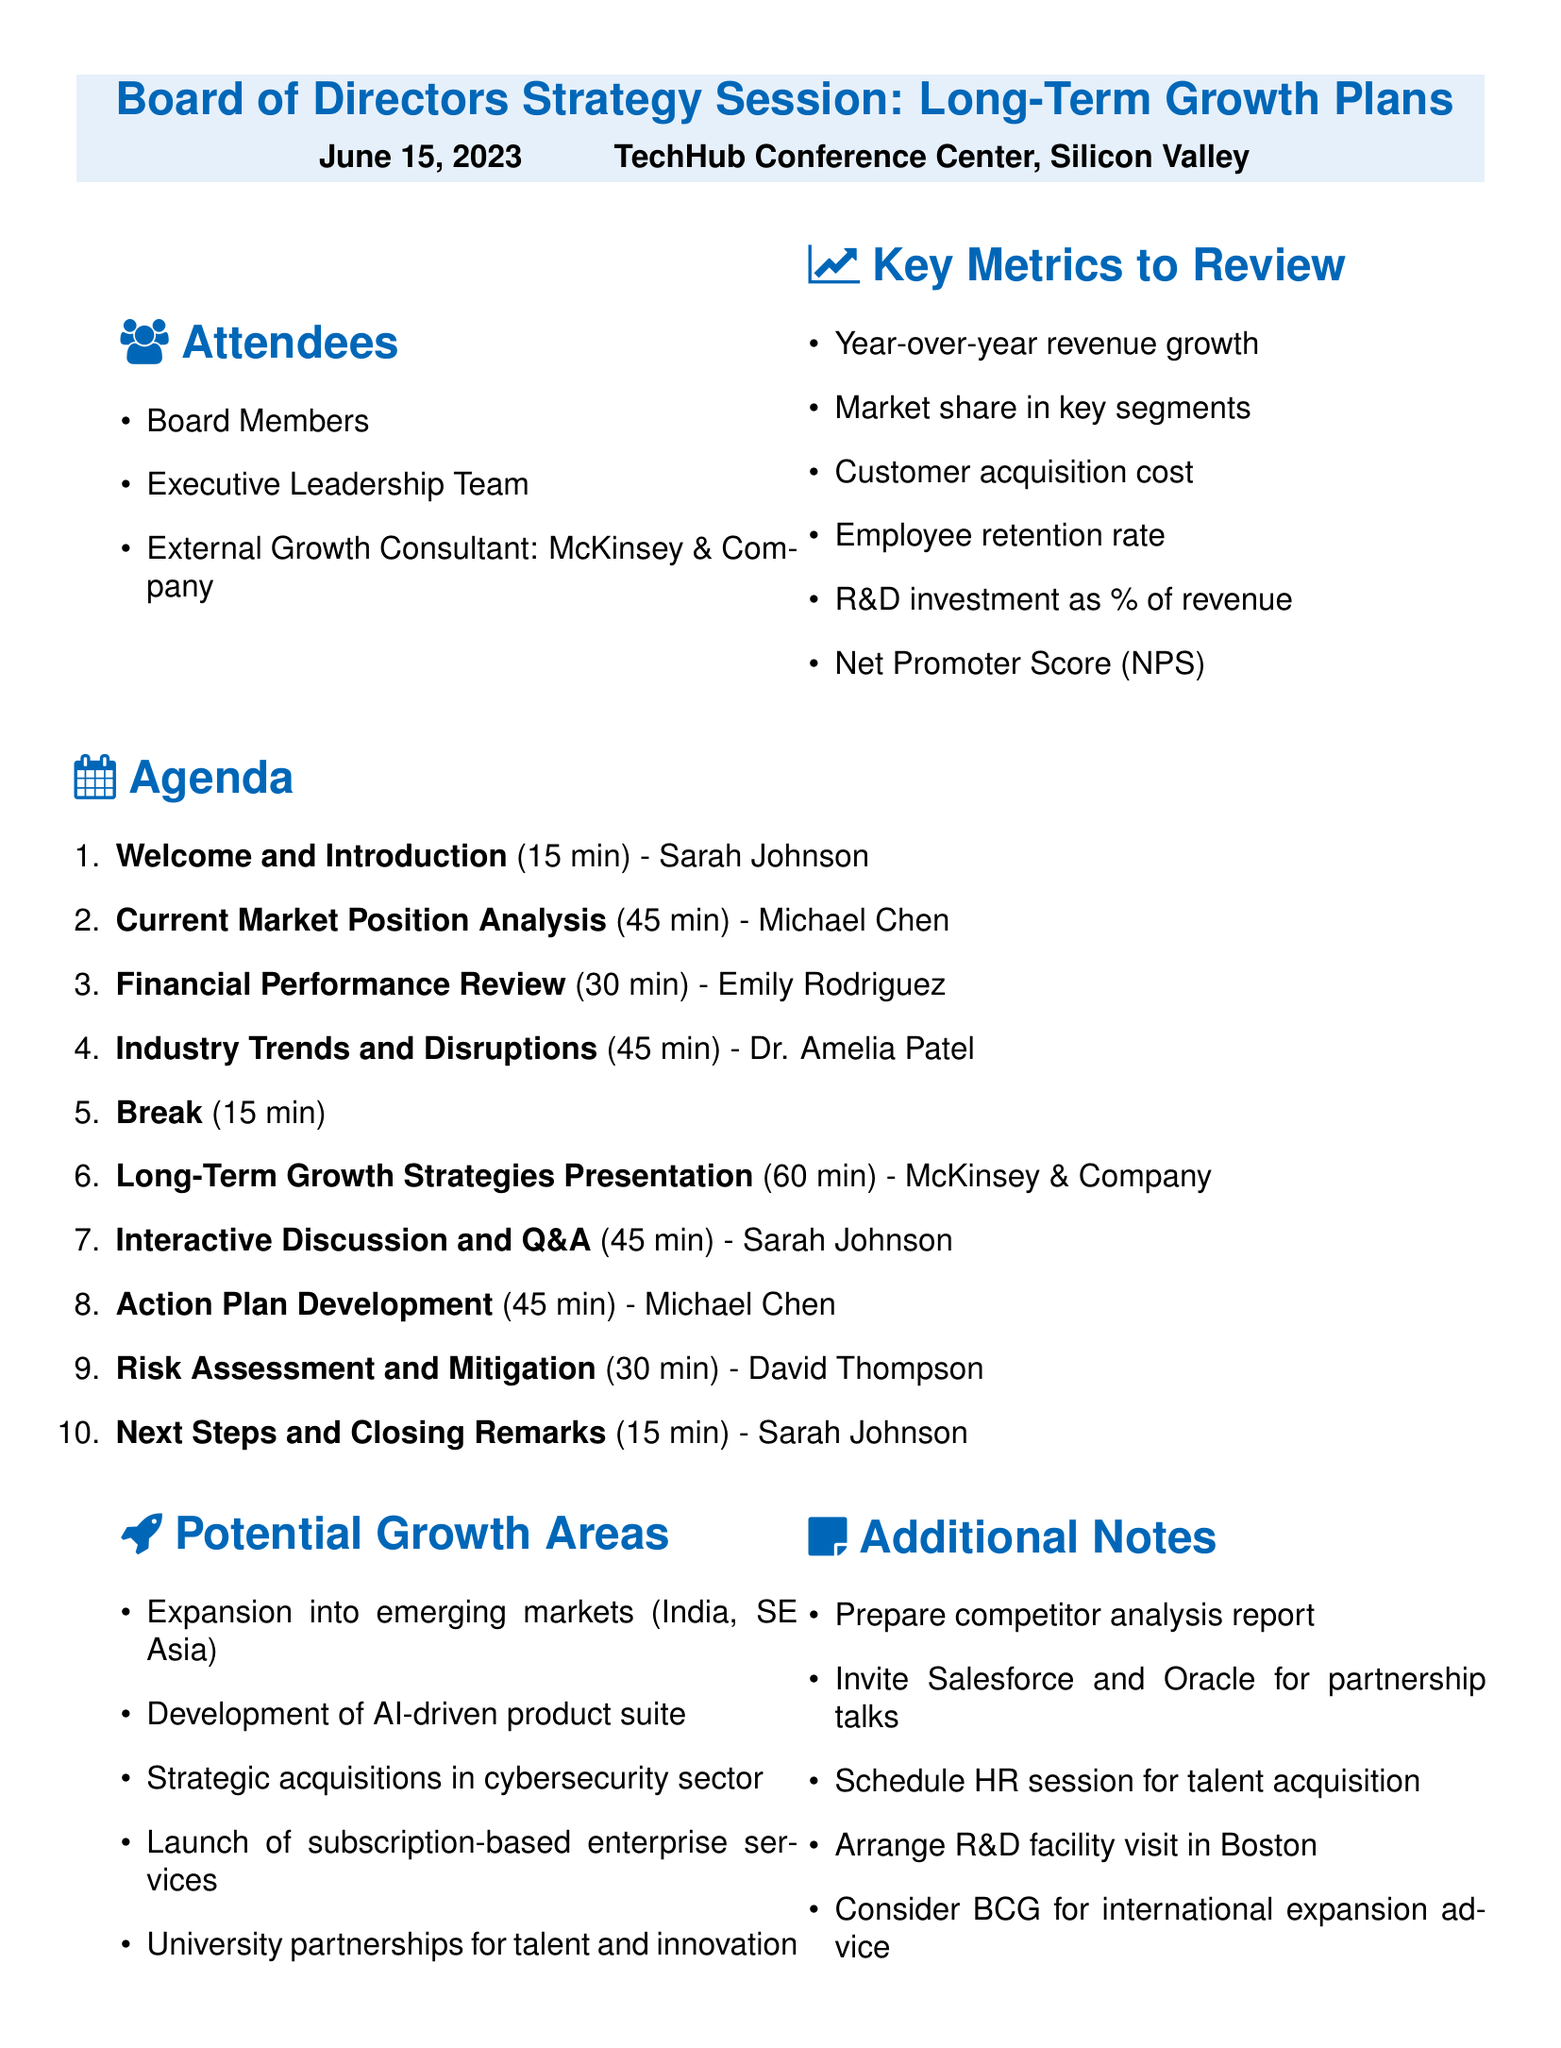What is the date of the strategy session? The document states the date of the session as June 15, 2023.
Answer: June 15, 2023 Who is the speaker for the Financial Performance Review? The agenda lists Emily Rodriguez as the speaker for this segment.
Answer: Emily Rodriguez How long is the interactive discussion and Q&A scheduled for? The agenda specifies that this segment lasts for 45 minutes.
Answer: 45 minutes What is one potential growth area mentioned? The document outlines several potential growth areas; one listed is "Expansion into emerging markets."
Answer: Expansion into emerging markets Who will facilitate the Action Plan Development session? The agenda indicates that Michael Chen will facilitate this session.
Answer: Michael Chen What is the duration of the break in the agenda? The break is scheduled for 15 minutes according to the agenda.
Answer: 15 minutes What is the key metric related to customer satisfaction? The document mentions the Net Promoter Score (NPS) as a key metric related to customer satisfaction.
Answer: Net Promoter Score (NPS) What external consultancy is attending the session? The agenda includes McKinsey & Company as the external growth consultant.
Answer: McKinsey & Company 